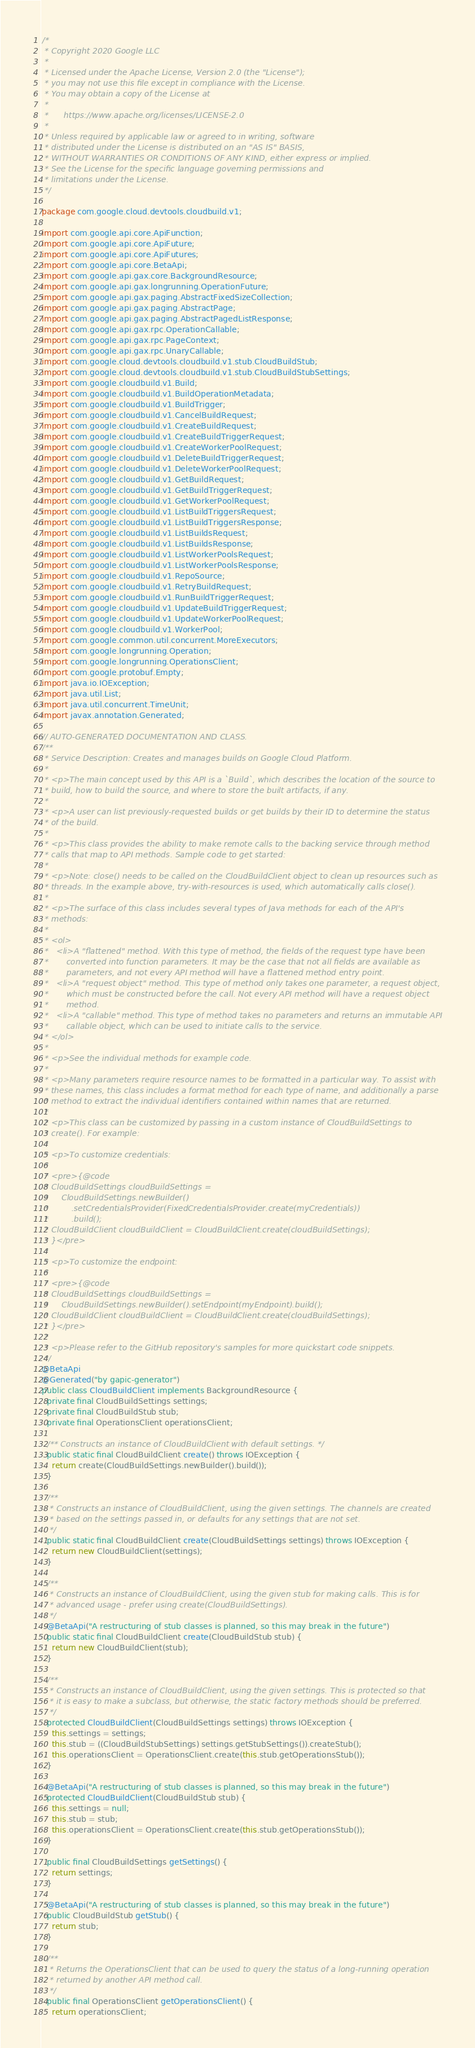Convert code to text. <code><loc_0><loc_0><loc_500><loc_500><_Java_>/*
 * Copyright 2020 Google LLC
 *
 * Licensed under the Apache License, Version 2.0 (the "License");
 * you may not use this file except in compliance with the License.
 * You may obtain a copy of the License at
 *
 *      https://www.apache.org/licenses/LICENSE-2.0
 *
 * Unless required by applicable law or agreed to in writing, software
 * distributed under the License is distributed on an "AS IS" BASIS,
 * WITHOUT WARRANTIES OR CONDITIONS OF ANY KIND, either express or implied.
 * See the License for the specific language governing permissions and
 * limitations under the License.
 */

package com.google.cloud.devtools.cloudbuild.v1;

import com.google.api.core.ApiFunction;
import com.google.api.core.ApiFuture;
import com.google.api.core.ApiFutures;
import com.google.api.core.BetaApi;
import com.google.api.gax.core.BackgroundResource;
import com.google.api.gax.longrunning.OperationFuture;
import com.google.api.gax.paging.AbstractFixedSizeCollection;
import com.google.api.gax.paging.AbstractPage;
import com.google.api.gax.paging.AbstractPagedListResponse;
import com.google.api.gax.rpc.OperationCallable;
import com.google.api.gax.rpc.PageContext;
import com.google.api.gax.rpc.UnaryCallable;
import com.google.cloud.devtools.cloudbuild.v1.stub.CloudBuildStub;
import com.google.cloud.devtools.cloudbuild.v1.stub.CloudBuildStubSettings;
import com.google.cloudbuild.v1.Build;
import com.google.cloudbuild.v1.BuildOperationMetadata;
import com.google.cloudbuild.v1.BuildTrigger;
import com.google.cloudbuild.v1.CancelBuildRequest;
import com.google.cloudbuild.v1.CreateBuildRequest;
import com.google.cloudbuild.v1.CreateBuildTriggerRequest;
import com.google.cloudbuild.v1.CreateWorkerPoolRequest;
import com.google.cloudbuild.v1.DeleteBuildTriggerRequest;
import com.google.cloudbuild.v1.DeleteWorkerPoolRequest;
import com.google.cloudbuild.v1.GetBuildRequest;
import com.google.cloudbuild.v1.GetBuildTriggerRequest;
import com.google.cloudbuild.v1.GetWorkerPoolRequest;
import com.google.cloudbuild.v1.ListBuildTriggersRequest;
import com.google.cloudbuild.v1.ListBuildTriggersResponse;
import com.google.cloudbuild.v1.ListBuildsRequest;
import com.google.cloudbuild.v1.ListBuildsResponse;
import com.google.cloudbuild.v1.ListWorkerPoolsRequest;
import com.google.cloudbuild.v1.ListWorkerPoolsResponse;
import com.google.cloudbuild.v1.RepoSource;
import com.google.cloudbuild.v1.RetryBuildRequest;
import com.google.cloudbuild.v1.RunBuildTriggerRequest;
import com.google.cloudbuild.v1.UpdateBuildTriggerRequest;
import com.google.cloudbuild.v1.UpdateWorkerPoolRequest;
import com.google.cloudbuild.v1.WorkerPool;
import com.google.common.util.concurrent.MoreExecutors;
import com.google.longrunning.Operation;
import com.google.longrunning.OperationsClient;
import com.google.protobuf.Empty;
import java.io.IOException;
import java.util.List;
import java.util.concurrent.TimeUnit;
import javax.annotation.Generated;

// AUTO-GENERATED DOCUMENTATION AND CLASS.
/**
 * Service Description: Creates and manages builds on Google Cloud Platform.
 *
 * <p>The main concept used by this API is a `Build`, which describes the location of the source to
 * build, how to build the source, and where to store the built artifacts, if any.
 *
 * <p>A user can list previously-requested builds or get builds by their ID to determine the status
 * of the build.
 *
 * <p>This class provides the ability to make remote calls to the backing service through method
 * calls that map to API methods. Sample code to get started:
 *
 * <p>Note: close() needs to be called on the CloudBuildClient object to clean up resources such as
 * threads. In the example above, try-with-resources is used, which automatically calls close().
 *
 * <p>The surface of this class includes several types of Java methods for each of the API's
 * methods:
 *
 * <ol>
 *   <li>A "flattened" method. With this type of method, the fields of the request type have been
 *       converted into function parameters. It may be the case that not all fields are available as
 *       parameters, and not every API method will have a flattened method entry point.
 *   <li>A "request object" method. This type of method only takes one parameter, a request object,
 *       which must be constructed before the call. Not every API method will have a request object
 *       method.
 *   <li>A "callable" method. This type of method takes no parameters and returns an immutable API
 *       callable object, which can be used to initiate calls to the service.
 * </ol>
 *
 * <p>See the individual methods for example code.
 *
 * <p>Many parameters require resource names to be formatted in a particular way. To assist with
 * these names, this class includes a format method for each type of name, and additionally a parse
 * method to extract the individual identifiers contained within names that are returned.
 *
 * <p>This class can be customized by passing in a custom instance of CloudBuildSettings to
 * create(). For example:
 *
 * <p>To customize credentials:
 *
 * <pre>{@code
 * CloudBuildSettings cloudBuildSettings =
 *     CloudBuildSettings.newBuilder()
 *         .setCredentialsProvider(FixedCredentialsProvider.create(myCredentials))
 *         .build();
 * CloudBuildClient cloudBuildClient = CloudBuildClient.create(cloudBuildSettings);
 * }</pre>
 *
 * <p>To customize the endpoint:
 *
 * <pre>{@code
 * CloudBuildSettings cloudBuildSettings =
 *     CloudBuildSettings.newBuilder().setEndpoint(myEndpoint).build();
 * CloudBuildClient cloudBuildClient = CloudBuildClient.create(cloudBuildSettings);
 * }</pre>
 *
 * <p>Please refer to the GitHub repository's samples for more quickstart code snippets.
 */
@BetaApi
@Generated("by gapic-generator")
public class CloudBuildClient implements BackgroundResource {
  private final CloudBuildSettings settings;
  private final CloudBuildStub stub;
  private final OperationsClient operationsClient;

  /** Constructs an instance of CloudBuildClient with default settings. */
  public static final CloudBuildClient create() throws IOException {
    return create(CloudBuildSettings.newBuilder().build());
  }

  /**
   * Constructs an instance of CloudBuildClient, using the given settings. The channels are created
   * based on the settings passed in, or defaults for any settings that are not set.
   */
  public static final CloudBuildClient create(CloudBuildSettings settings) throws IOException {
    return new CloudBuildClient(settings);
  }

  /**
   * Constructs an instance of CloudBuildClient, using the given stub for making calls. This is for
   * advanced usage - prefer using create(CloudBuildSettings).
   */
  @BetaApi("A restructuring of stub classes is planned, so this may break in the future")
  public static final CloudBuildClient create(CloudBuildStub stub) {
    return new CloudBuildClient(stub);
  }

  /**
   * Constructs an instance of CloudBuildClient, using the given settings. This is protected so that
   * it is easy to make a subclass, but otherwise, the static factory methods should be preferred.
   */
  protected CloudBuildClient(CloudBuildSettings settings) throws IOException {
    this.settings = settings;
    this.stub = ((CloudBuildStubSettings) settings.getStubSettings()).createStub();
    this.operationsClient = OperationsClient.create(this.stub.getOperationsStub());
  }

  @BetaApi("A restructuring of stub classes is planned, so this may break in the future")
  protected CloudBuildClient(CloudBuildStub stub) {
    this.settings = null;
    this.stub = stub;
    this.operationsClient = OperationsClient.create(this.stub.getOperationsStub());
  }

  public final CloudBuildSettings getSettings() {
    return settings;
  }

  @BetaApi("A restructuring of stub classes is planned, so this may break in the future")
  public CloudBuildStub getStub() {
    return stub;
  }

  /**
   * Returns the OperationsClient that can be used to query the status of a long-running operation
   * returned by another API method call.
   */
  public final OperationsClient getOperationsClient() {
    return operationsClient;</code> 